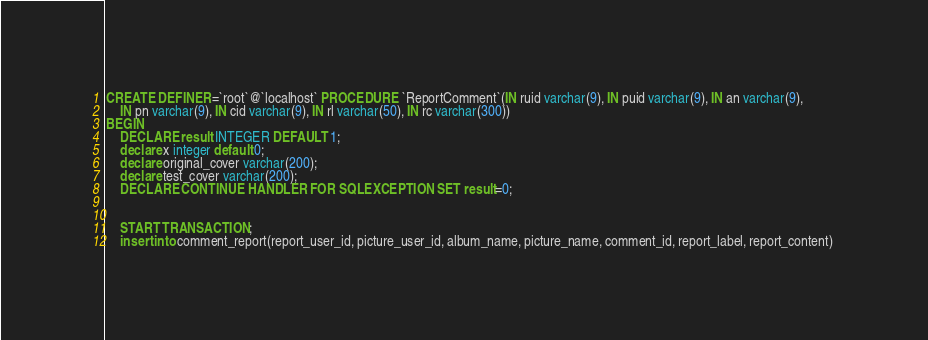<code> <loc_0><loc_0><loc_500><loc_500><_SQL_>CREATE DEFINER=`root`@`localhost` PROCEDURE `ReportComment`(IN ruid varchar(9), IN puid varchar(9), IN an varchar(9), 
	IN pn varchar(9), IN cid varchar(9), IN rl varchar(50), IN rc varchar(300))
BEGIN
    DECLARE result INTEGER DEFAULT 1;  
	declare x integer default 0;
    declare original_cover varchar(200);
    declare test_cover varchar(200);
	DECLARE CONTINUE HANDLER FOR SQLEXCEPTION SET result=0;  

    
	START TRANSACTION;
    insert into comment_report(report_user_id, picture_user_id, album_name, picture_name, comment_id, report_label, report_content) </code> 